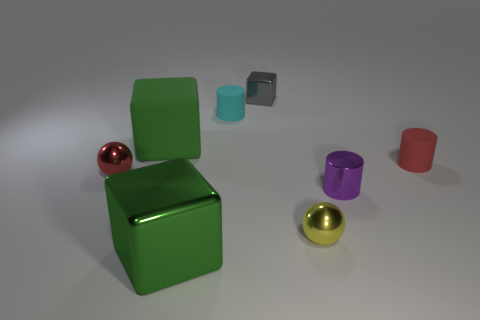Are there any other things that have the same color as the metal cylinder?
Offer a terse response. No. Are there any tiny cyan rubber things that have the same shape as the small yellow metal thing?
Provide a succinct answer. No. There is a green object behind the rubber cylinder that is on the right side of the small gray thing; what shape is it?
Keep it short and to the point. Cube. There is a large thing in front of the red matte cylinder; what shape is it?
Make the answer very short. Cube. There is a ball that is behind the small purple metal cylinder; is it the same color as the small rubber thing in front of the cyan matte thing?
Provide a succinct answer. Yes. How many small cylinders are both in front of the big green rubber cube and to the left of the tiny purple cylinder?
Keep it short and to the point. 0. What size is the yellow sphere that is the same material as the tiny purple cylinder?
Keep it short and to the point. Small. What is the size of the cyan thing?
Your response must be concise. Small. What material is the tiny cyan cylinder?
Ensure brevity in your answer.  Rubber. Does the object that is to the right of the purple cylinder have the same size as the small cyan cylinder?
Your answer should be very brief. Yes. 